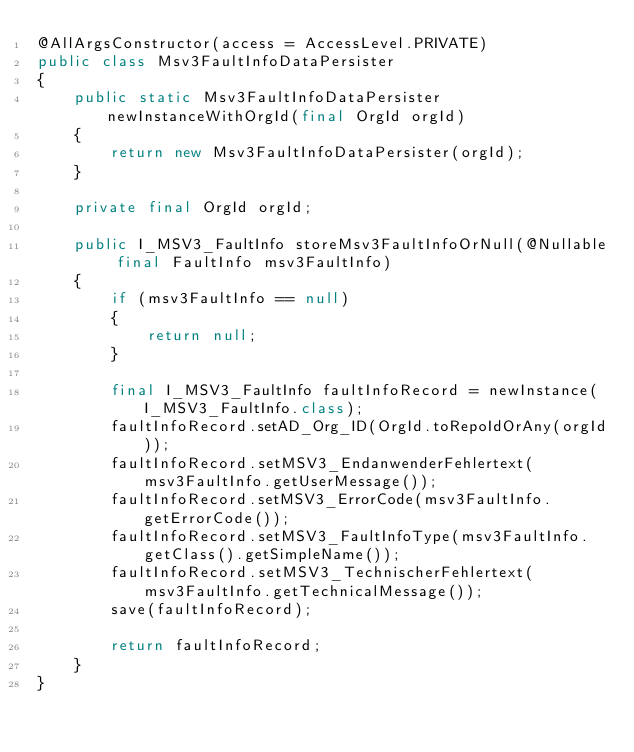<code> <loc_0><loc_0><loc_500><loc_500><_Java_>@AllArgsConstructor(access = AccessLevel.PRIVATE)
public class Msv3FaultInfoDataPersister
{
	public static Msv3FaultInfoDataPersister newInstanceWithOrgId(final OrgId orgId)
	{
		return new Msv3FaultInfoDataPersister(orgId);
	}

	private final OrgId orgId;

	public I_MSV3_FaultInfo storeMsv3FaultInfoOrNull(@Nullable final FaultInfo msv3FaultInfo)
	{
		if (msv3FaultInfo == null)
		{
			return null;
		}

		final I_MSV3_FaultInfo faultInfoRecord = newInstance(I_MSV3_FaultInfo.class);
		faultInfoRecord.setAD_Org_ID(OrgId.toRepoIdOrAny(orgId));
		faultInfoRecord.setMSV3_EndanwenderFehlertext(msv3FaultInfo.getUserMessage());
		faultInfoRecord.setMSV3_ErrorCode(msv3FaultInfo.getErrorCode());
		faultInfoRecord.setMSV3_FaultInfoType(msv3FaultInfo.getClass().getSimpleName());
		faultInfoRecord.setMSV3_TechnischerFehlertext(msv3FaultInfo.getTechnicalMessage());
		save(faultInfoRecord);

		return faultInfoRecord;
	}
}
</code> 